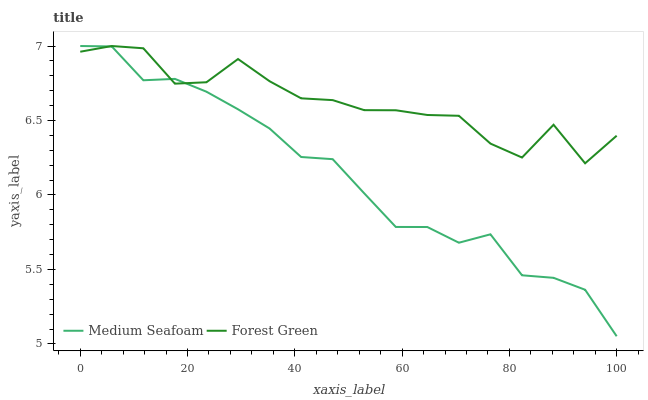Does Medium Seafoam have the minimum area under the curve?
Answer yes or no. Yes. Does Forest Green have the maximum area under the curve?
Answer yes or no. Yes. Does Medium Seafoam have the maximum area under the curve?
Answer yes or no. No. Is Medium Seafoam the smoothest?
Answer yes or no. Yes. Is Forest Green the roughest?
Answer yes or no. Yes. Is Medium Seafoam the roughest?
Answer yes or no. No. Does Medium Seafoam have the highest value?
Answer yes or no. Yes. Does Medium Seafoam intersect Forest Green?
Answer yes or no. Yes. Is Medium Seafoam less than Forest Green?
Answer yes or no. No. Is Medium Seafoam greater than Forest Green?
Answer yes or no. No. 